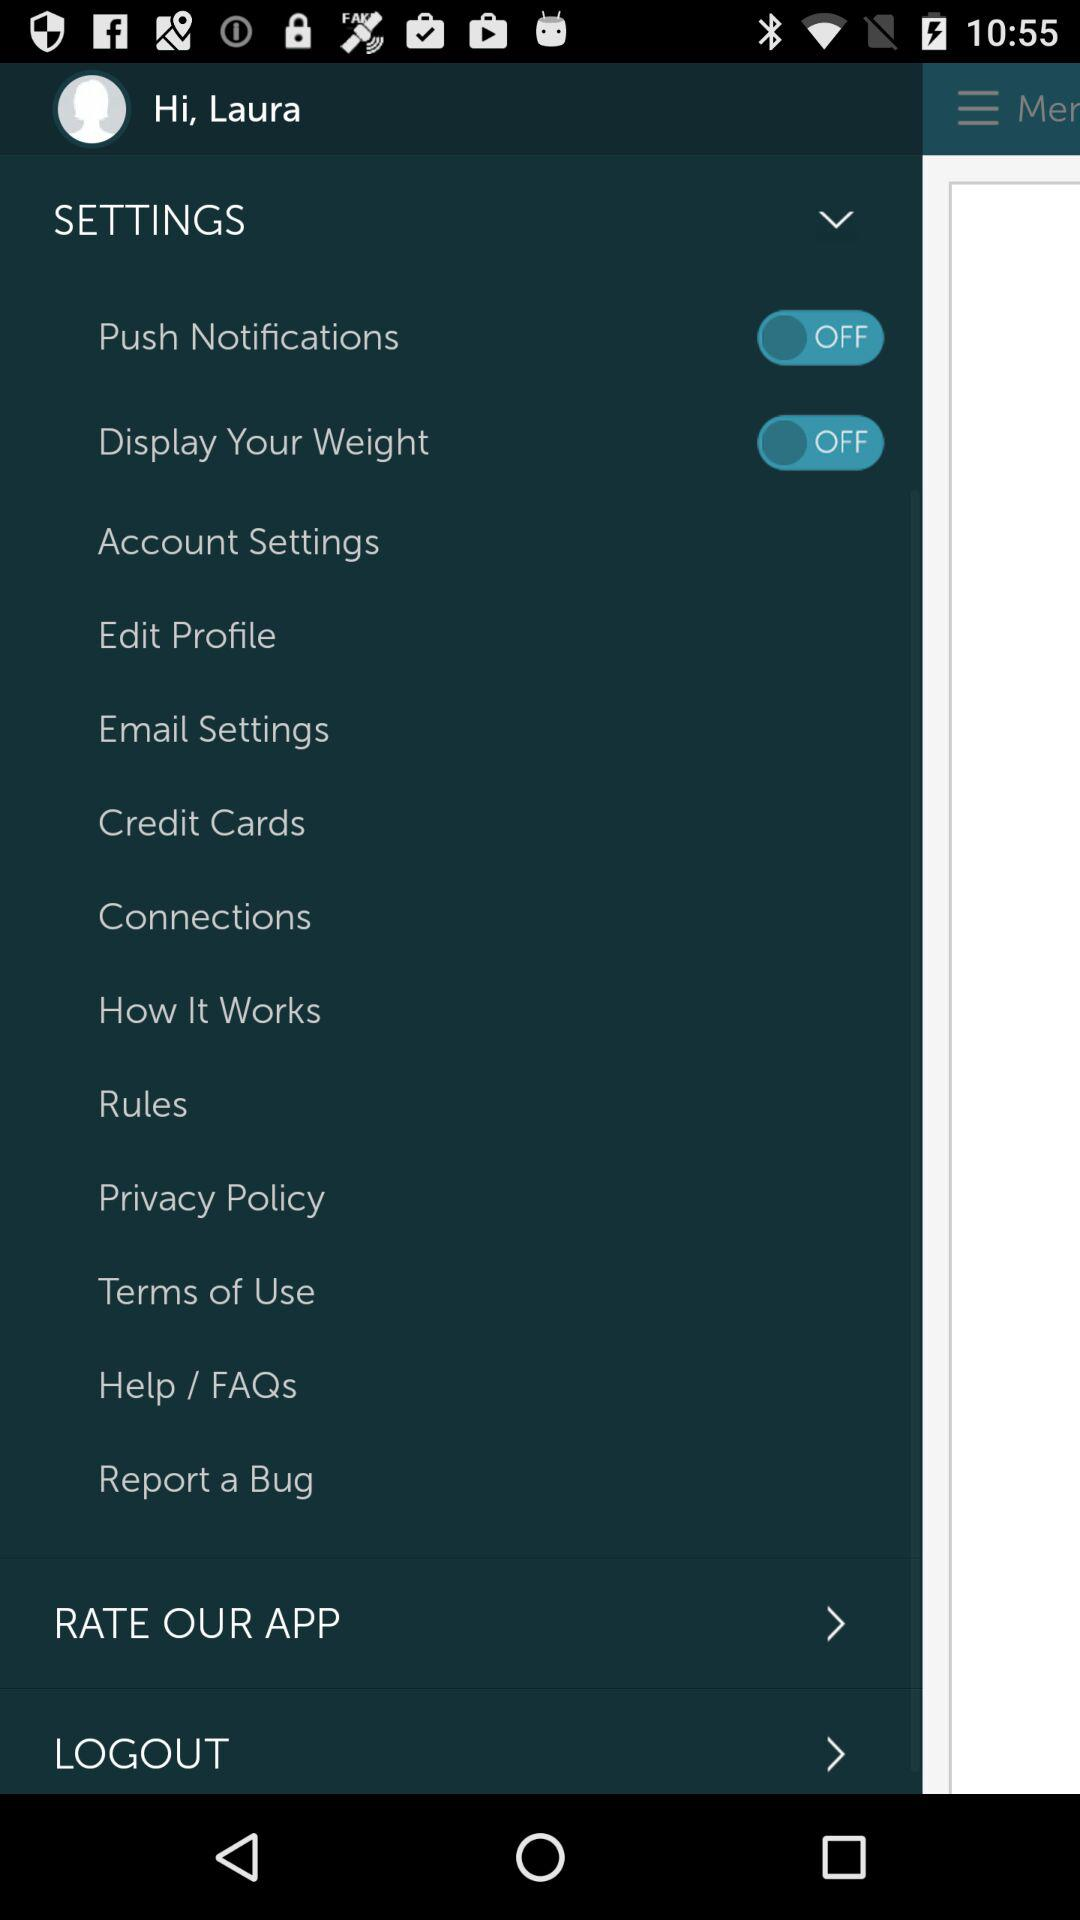What is the name? The name is Laura. 